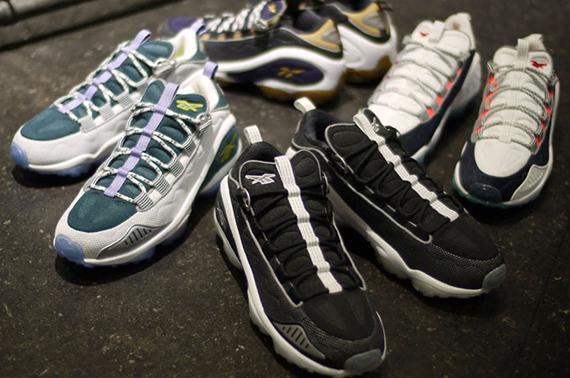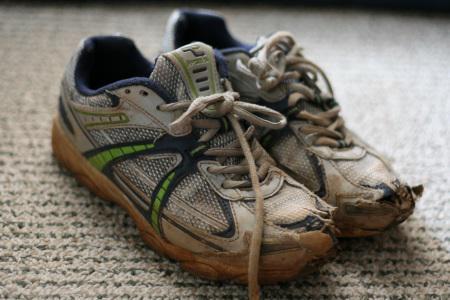The first image is the image on the left, the second image is the image on the right. Analyze the images presented: Is the assertion "There are at least four pairs of shoes." valid? Answer yes or no. Yes. The first image is the image on the left, the second image is the image on the right. Analyze the images presented: Is the assertion "Some sneakers are brand new and some are not." valid? Answer yes or no. Yes. 